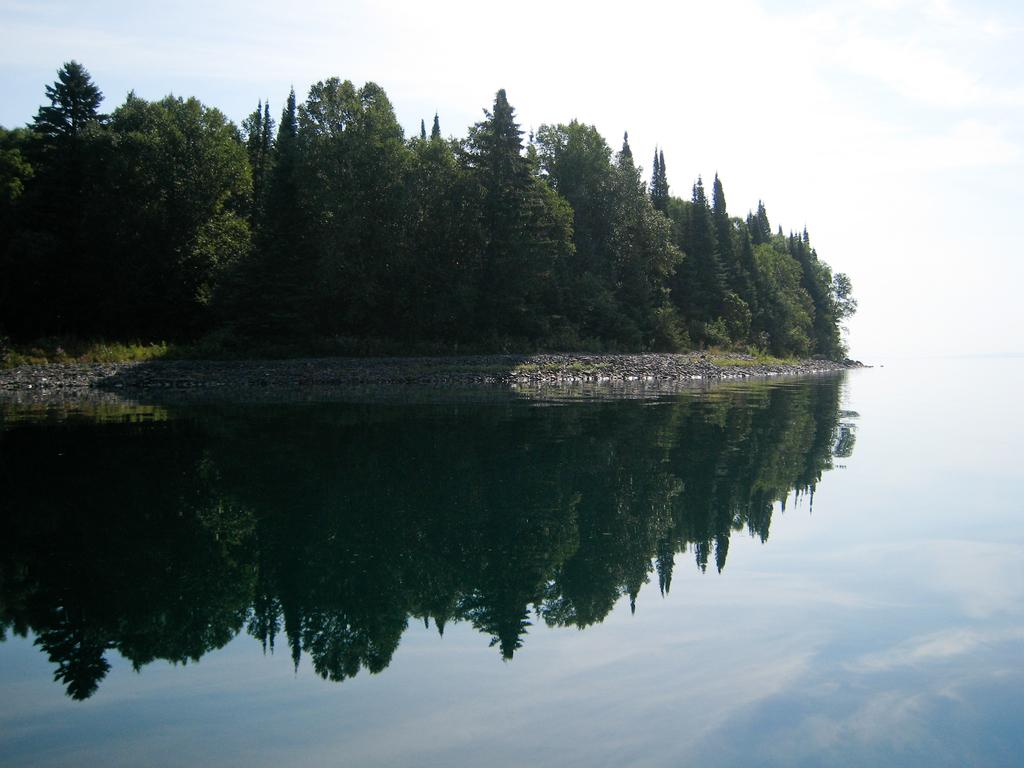What type of landscape is depicted in the image? The image features a water body, trees, and grass in the background. What can be seen in the sky in the image? The sky is visible at the top of the image. How many kittens are playing on the trail near the water body in the image? There is no trail or kittens present in the image. 